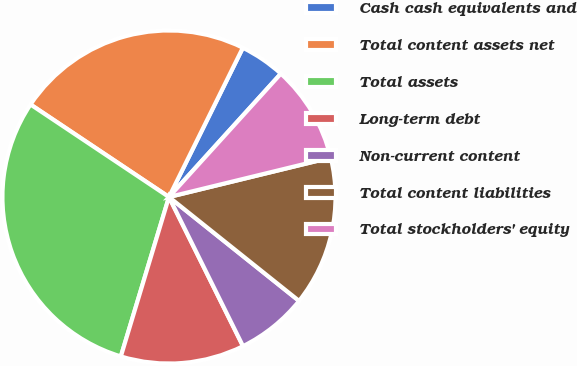Convert chart. <chart><loc_0><loc_0><loc_500><loc_500><pie_chart><fcel>Cash cash equivalents and<fcel>Total content assets net<fcel>Total assets<fcel>Long-term debt<fcel>Non-current content<fcel>Total content liabilities<fcel>Total stockholders' equity<nl><fcel>4.41%<fcel>22.94%<fcel>29.71%<fcel>12.0%<fcel>6.94%<fcel>14.53%<fcel>9.47%<nl></chart> 